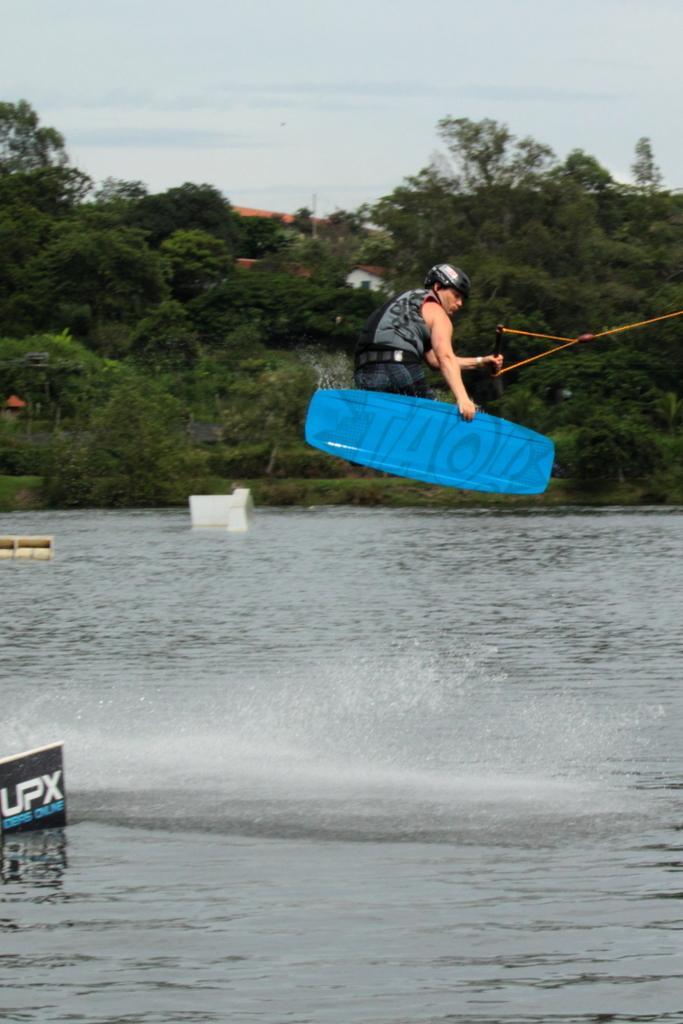Can you describe this image briefly? This image is taken outdoors. At the bottom of the image there is a river. At the top of the image there is a sky with clouds. In the background there are many trees and plants and there is a house. In the middle of the image there is a man and he is holding a rope and a surfing board with his hands. On the left side of the image there is a board with a text on it. 